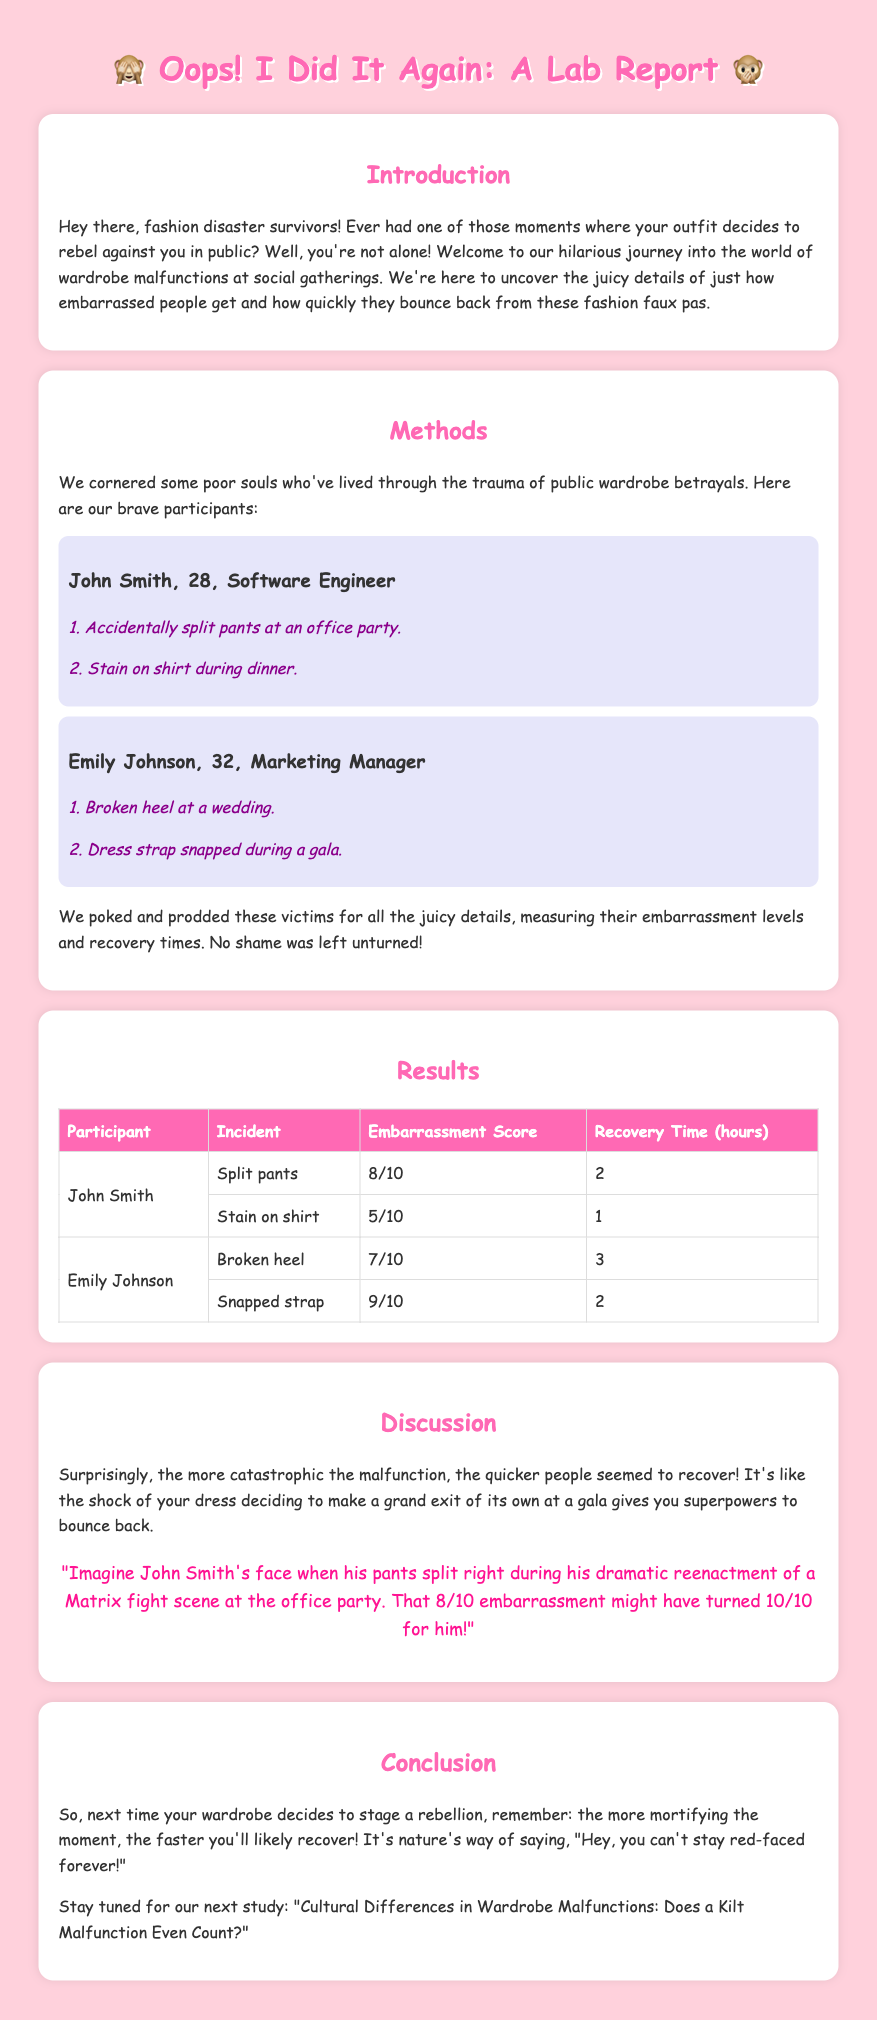what is the title of the report? The title is prominently displayed at the top of the document.
Answer: Oops! I Did It Again: A Lab Report how many incidents did John Smith experience? The document states two specific incidents involving John Smith.
Answer: 2 what was the embarrassment score for Emily Johnson's snapped strap incident? The embarrassment score for the snapped strap incident is listed in the results table.
Answer: 9/10 what is the recovery time for John Smith's stain on shirt incident? The recovery time for the stain on shirt is mentioned in the results section for John Smith.
Answer: 1 what is the overall trend discussed in the report regarding embarrassment and recovery time? The discussion explains the relationship between embarrassment levels and recovery times.
Answer: quicker recovery with more embarrassment who experienced a broken heel? The document identifies participants alongside their incidents, including the broken heel.
Answer: Emily Johnson how long did it take for Emily Johnson to recover from her broken heel incident? The recovery time for the broken heel incident is specified in the results table.
Answer: 3 what is the structure of the report? The report contains various sections that categorize the findings and discussions on wardrobe malfunctions.
Answer: Introduction, Methods, Results, Discussion, Conclusion 